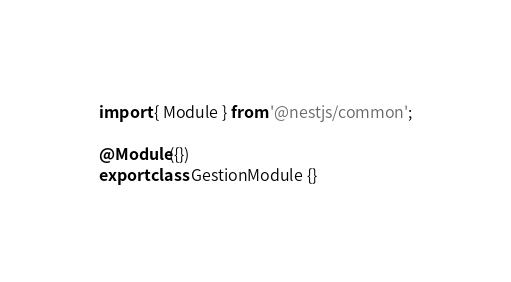Convert code to text. <code><loc_0><loc_0><loc_500><loc_500><_TypeScript_>import { Module } from '@nestjs/common';

@Module({})
export class GestionModule {}
</code> 